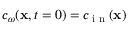<formula> <loc_0><loc_0><loc_500><loc_500>c _ { \omega } ( x , t = 0 ) = c _ { i n } ( x )</formula> 